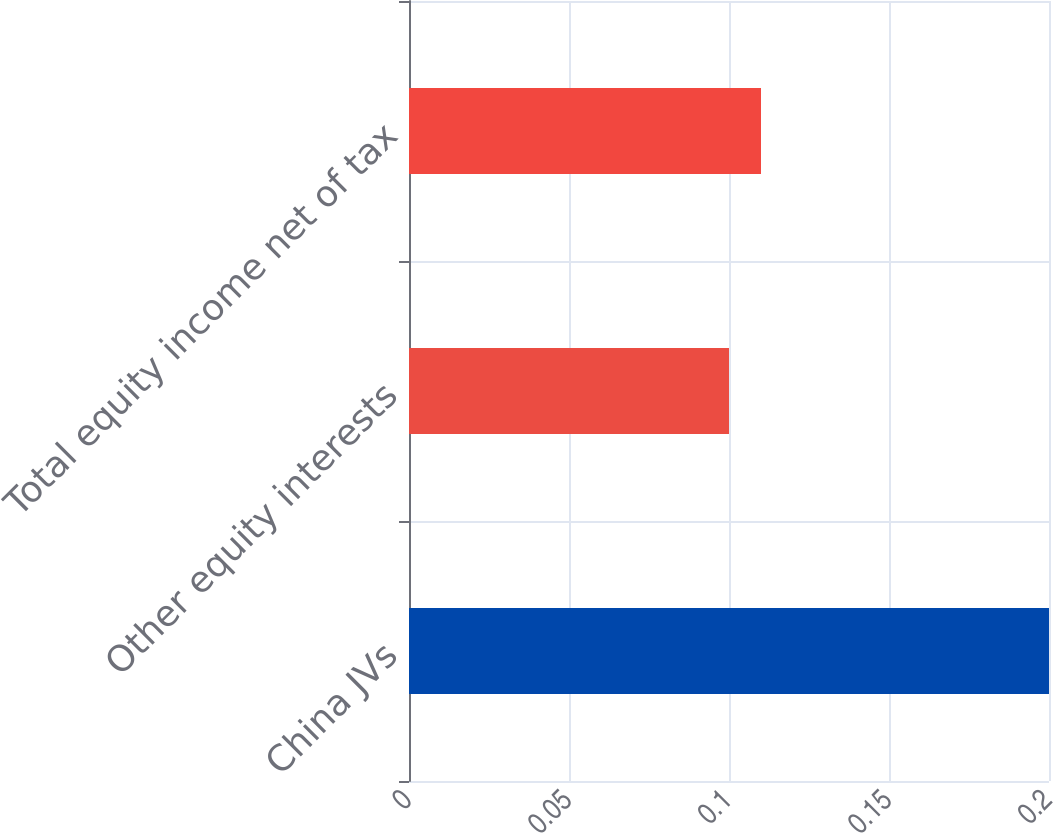Convert chart. <chart><loc_0><loc_0><loc_500><loc_500><bar_chart><fcel>China JVs<fcel>Other equity interests<fcel>Total equity income net of tax<nl><fcel>0.2<fcel>0.1<fcel>0.11<nl></chart> 